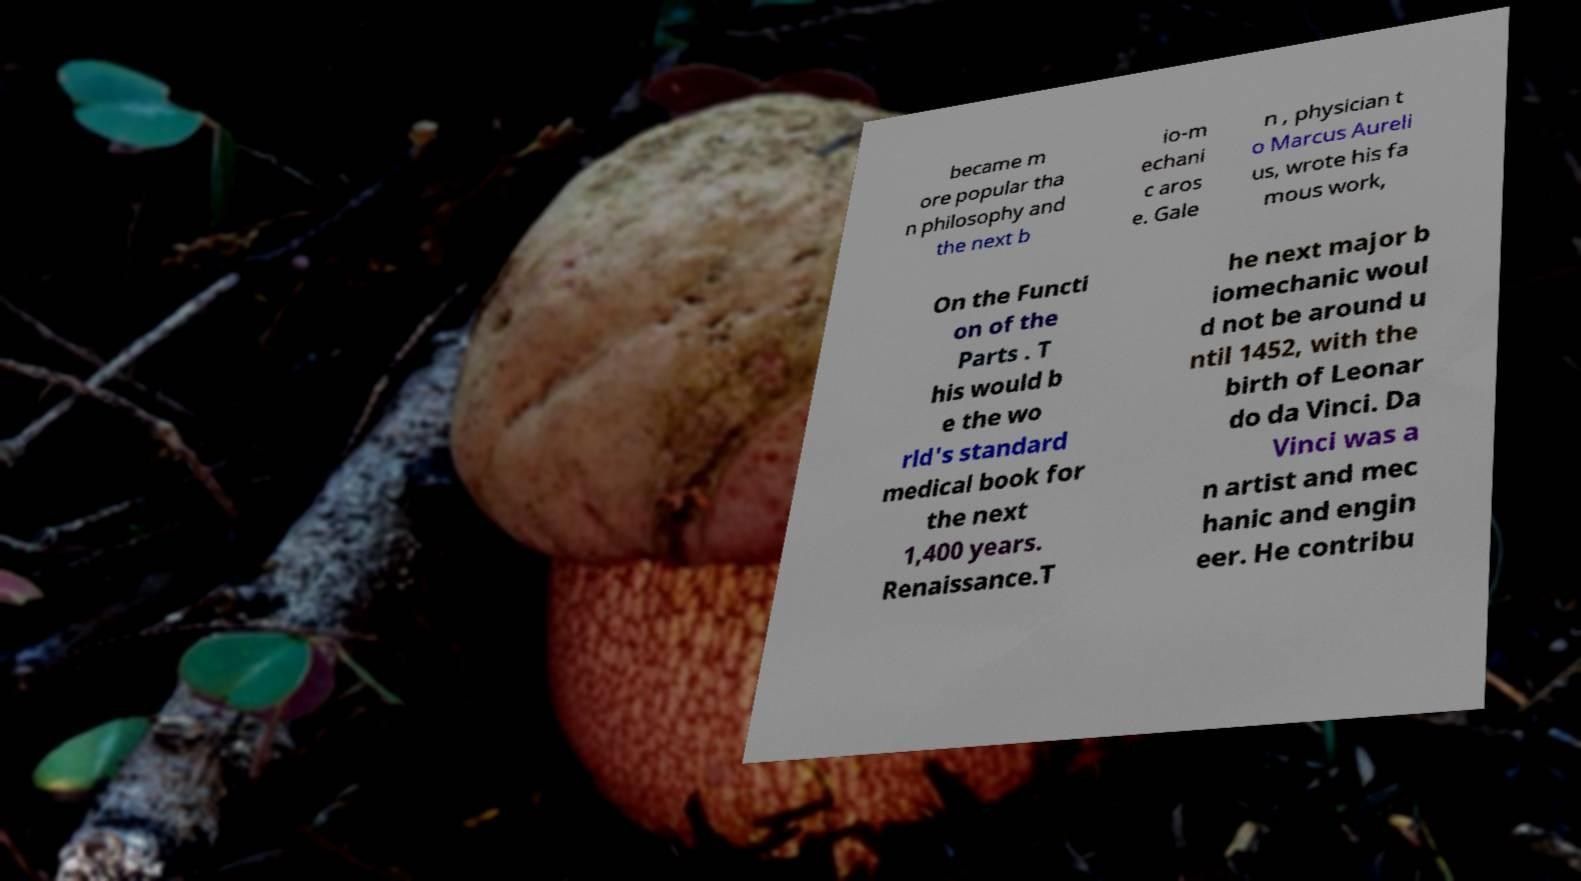I need the written content from this picture converted into text. Can you do that? became m ore popular tha n philosophy and the next b io-m echani c aros e. Gale n , physician t o Marcus Aureli us, wrote his fa mous work, On the Functi on of the Parts . T his would b e the wo rld's standard medical book for the next 1,400 years. Renaissance.T he next major b iomechanic woul d not be around u ntil 1452, with the birth of Leonar do da Vinci. Da Vinci was a n artist and mec hanic and engin eer. He contribu 